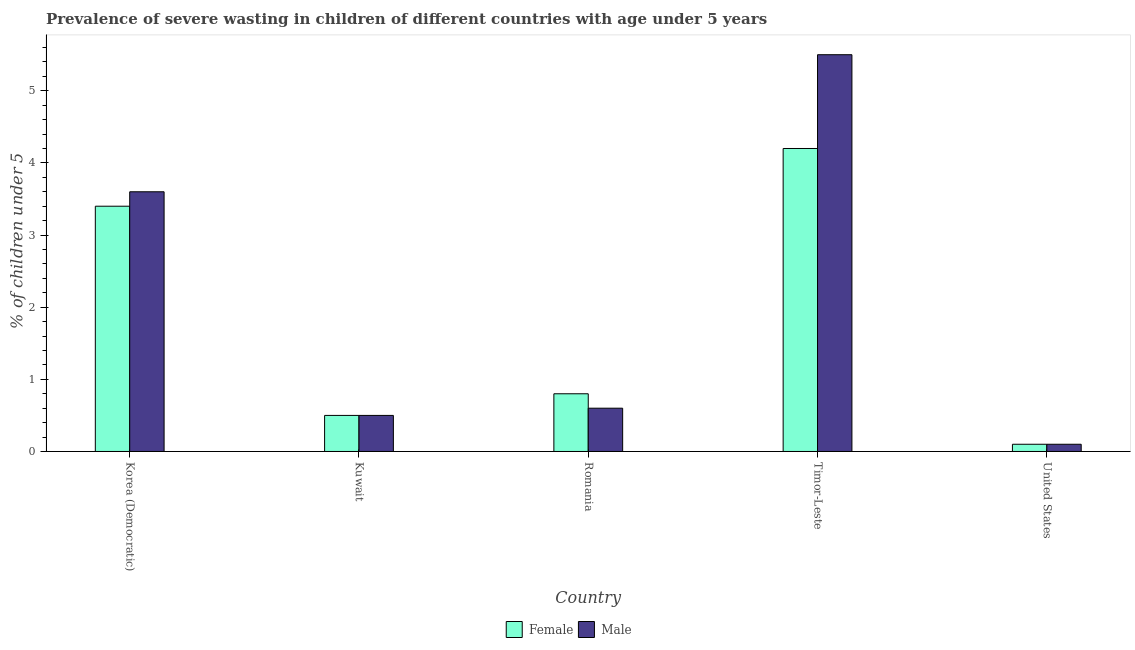Are the number of bars per tick equal to the number of legend labels?
Provide a short and direct response. Yes. How many bars are there on the 4th tick from the left?
Provide a succinct answer. 2. What is the label of the 4th group of bars from the left?
Provide a succinct answer. Timor-Leste. What is the percentage of undernourished male children in Romania?
Your response must be concise. 0.6. Across all countries, what is the maximum percentage of undernourished female children?
Ensure brevity in your answer.  4.2. Across all countries, what is the minimum percentage of undernourished male children?
Keep it short and to the point. 0.1. In which country was the percentage of undernourished male children maximum?
Keep it short and to the point. Timor-Leste. What is the total percentage of undernourished female children in the graph?
Offer a terse response. 9. What is the difference between the percentage of undernourished male children in Kuwait and that in Romania?
Your answer should be compact. -0.1. What is the difference between the percentage of undernourished male children in Korea (Democratic) and the percentage of undernourished female children in Timor-Leste?
Give a very brief answer. -0.6. What is the average percentage of undernourished female children per country?
Make the answer very short. 1.8. What is the difference between the percentage of undernourished male children and percentage of undernourished female children in Korea (Democratic)?
Your answer should be compact. 0.2. What is the ratio of the percentage of undernourished female children in Romania to that in Timor-Leste?
Your response must be concise. 0.19. Is the percentage of undernourished male children in Kuwait less than that in Romania?
Keep it short and to the point. Yes. Is the difference between the percentage of undernourished female children in Korea (Democratic) and Romania greater than the difference between the percentage of undernourished male children in Korea (Democratic) and Romania?
Offer a very short reply. No. What is the difference between the highest and the second highest percentage of undernourished male children?
Keep it short and to the point. 1.9. What is the difference between the highest and the lowest percentage of undernourished male children?
Offer a terse response. 5.4. In how many countries, is the percentage of undernourished female children greater than the average percentage of undernourished female children taken over all countries?
Give a very brief answer. 2. What does the 2nd bar from the left in Timor-Leste represents?
Make the answer very short. Male. Are all the bars in the graph horizontal?
Ensure brevity in your answer.  No. How many countries are there in the graph?
Provide a succinct answer. 5. What is the difference between two consecutive major ticks on the Y-axis?
Your answer should be compact. 1. Are the values on the major ticks of Y-axis written in scientific E-notation?
Provide a short and direct response. No. Does the graph contain any zero values?
Provide a succinct answer. No. Where does the legend appear in the graph?
Provide a short and direct response. Bottom center. How many legend labels are there?
Provide a succinct answer. 2. How are the legend labels stacked?
Keep it short and to the point. Horizontal. What is the title of the graph?
Keep it short and to the point. Prevalence of severe wasting in children of different countries with age under 5 years. What is the label or title of the Y-axis?
Keep it short and to the point.  % of children under 5. What is the  % of children under 5 in Female in Korea (Democratic)?
Keep it short and to the point. 3.4. What is the  % of children under 5 of Male in Korea (Democratic)?
Offer a terse response. 3.6. What is the  % of children under 5 of Female in Kuwait?
Make the answer very short. 0.5. What is the  % of children under 5 in Female in Romania?
Your answer should be compact. 0.8. What is the  % of children under 5 in Male in Romania?
Ensure brevity in your answer.  0.6. What is the  % of children under 5 of Female in Timor-Leste?
Your answer should be compact. 4.2. What is the  % of children under 5 in Female in United States?
Your answer should be compact. 0.1. What is the  % of children under 5 of Male in United States?
Provide a succinct answer. 0.1. Across all countries, what is the maximum  % of children under 5 of Female?
Provide a short and direct response. 4.2. Across all countries, what is the minimum  % of children under 5 in Female?
Ensure brevity in your answer.  0.1. Across all countries, what is the minimum  % of children under 5 in Male?
Your answer should be compact. 0.1. What is the total  % of children under 5 in Female in the graph?
Provide a succinct answer. 9. What is the total  % of children under 5 in Male in the graph?
Give a very brief answer. 10.3. What is the difference between the  % of children under 5 in Female in Korea (Democratic) and that in Romania?
Provide a succinct answer. 2.6. What is the difference between the  % of children under 5 of Male in Korea (Democratic) and that in Timor-Leste?
Your answer should be very brief. -1.9. What is the difference between the  % of children under 5 in Male in Korea (Democratic) and that in United States?
Give a very brief answer. 3.5. What is the difference between the  % of children under 5 in Male in Kuwait and that in Romania?
Offer a very short reply. -0.1. What is the difference between the  % of children under 5 of Female in Kuwait and that in Timor-Leste?
Offer a very short reply. -3.7. What is the difference between the  % of children under 5 of Female in Kuwait and that in United States?
Offer a terse response. 0.4. What is the difference between the  % of children under 5 of Female in Romania and that in Timor-Leste?
Your response must be concise. -3.4. What is the difference between the  % of children under 5 in Female in Romania and that in United States?
Give a very brief answer. 0.7. What is the difference between the  % of children under 5 in Female in Timor-Leste and that in United States?
Offer a very short reply. 4.1. What is the difference between the  % of children under 5 in Female in Korea (Democratic) and the  % of children under 5 in Male in Kuwait?
Offer a very short reply. 2.9. What is the difference between the  % of children under 5 of Female in Korea (Democratic) and the  % of children under 5 of Male in Romania?
Your response must be concise. 2.8. What is the difference between the  % of children under 5 in Female in Kuwait and the  % of children under 5 in Male in Romania?
Give a very brief answer. -0.1. What is the difference between the  % of children under 5 of Female in Kuwait and the  % of children under 5 of Male in Timor-Leste?
Your answer should be very brief. -5. What is the difference between the  % of children under 5 in Female in Romania and the  % of children under 5 in Male in Timor-Leste?
Keep it short and to the point. -4.7. What is the difference between the  % of children under 5 in Female in Romania and the  % of children under 5 in Male in United States?
Offer a very short reply. 0.7. What is the difference between the  % of children under 5 of Female in Timor-Leste and the  % of children under 5 of Male in United States?
Ensure brevity in your answer.  4.1. What is the average  % of children under 5 in Male per country?
Give a very brief answer. 2.06. What is the ratio of the  % of children under 5 in Female in Korea (Democratic) to that in Kuwait?
Give a very brief answer. 6.8. What is the ratio of the  % of children under 5 in Female in Korea (Democratic) to that in Romania?
Provide a short and direct response. 4.25. What is the ratio of the  % of children under 5 of Female in Korea (Democratic) to that in Timor-Leste?
Offer a very short reply. 0.81. What is the ratio of the  % of children under 5 in Male in Korea (Democratic) to that in Timor-Leste?
Keep it short and to the point. 0.65. What is the ratio of the  % of children under 5 in Female in Korea (Democratic) to that in United States?
Provide a short and direct response. 34. What is the ratio of the  % of children under 5 of Female in Kuwait to that in Romania?
Ensure brevity in your answer.  0.62. What is the ratio of the  % of children under 5 of Male in Kuwait to that in Romania?
Your answer should be very brief. 0.83. What is the ratio of the  % of children under 5 in Female in Kuwait to that in Timor-Leste?
Keep it short and to the point. 0.12. What is the ratio of the  % of children under 5 of Male in Kuwait to that in Timor-Leste?
Your answer should be very brief. 0.09. What is the ratio of the  % of children under 5 in Female in Romania to that in Timor-Leste?
Offer a terse response. 0.19. What is the ratio of the  % of children under 5 of Male in Romania to that in Timor-Leste?
Give a very brief answer. 0.11. What is the difference between the highest and the second highest  % of children under 5 of Male?
Offer a very short reply. 1.9. What is the difference between the highest and the lowest  % of children under 5 of Female?
Keep it short and to the point. 4.1. 